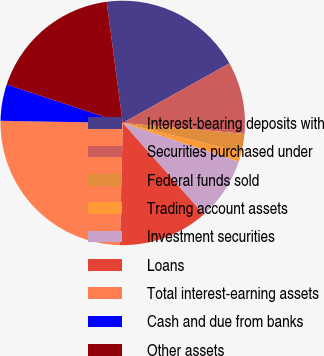<chart> <loc_0><loc_0><loc_500><loc_500><pie_chart><fcel>Interest-bearing deposits with<fcel>Securities purchased under<fcel>Federal funds sold<fcel>Trading account assets<fcel>Investment securities<fcel>Loans<fcel>Total interest-earning assets<fcel>Cash and due from banks<fcel>Other assets<nl><fcel>18.99%<fcel>9.53%<fcel>2.44%<fcel>1.26%<fcel>8.35%<fcel>11.9%<fcel>24.91%<fcel>4.81%<fcel>17.81%<nl></chart> 